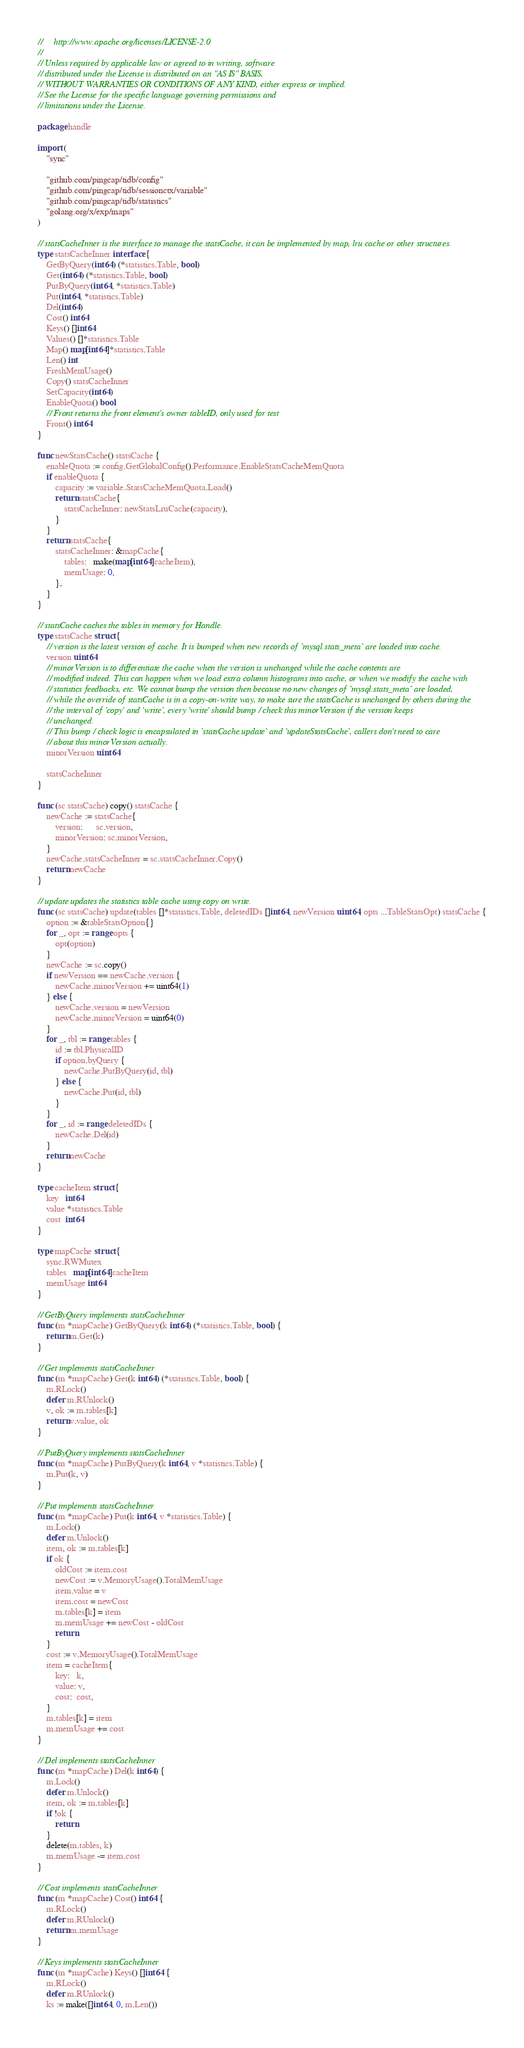<code> <loc_0><loc_0><loc_500><loc_500><_Go_>//     http://www.apache.org/licenses/LICENSE-2.0
//
// Unless required by applicable law or agreed to in writing, software
// distributed under the License is distributed on an "AS IS" BASIS,
// WITHOUT WARRANTIES OR CONDITIONS OF ANY KIND, either express or implied.
// See the License for the specific language governing permissions and
// limitations under the License.

package handle

import (
	"sync"

	"github.com/pingcap/tidb/config"
	"github.com/pingcap/tidb/sessionctx/variable"
	"github.com/pingcap/tidb/statistics"
	"golang.org/x/exp/maps"
)

// statsCacheInner is the interface to manage the statsCache, it can be implemented by map, lru cache or other structures.
type statsCacheInner interface {
	GetByQuery(int64) (*statistics.Table, bool)
	Get(int64) (*statistics.Table, bool)
	PutByQuery(int64, *statistics.Table)
	Put(int64, *statistics.Table)
	Del(int64)
	Cost() int64
	Keys() []int64
	Values() []*statistics.Table
	Map() map[int64]*statistics.Table
	Len() int
	FreshMemUsage()
	Copy() statsCacheInner
	SetCapacity(int64)
	EnableQuota() bool
	// Front returns the front element's owner tableID, only used for test
	Front() int64
}

func newStatsCache() statsCache {
	enableQuota := config.GetGlobalConfig().Performance.EnableStatsCacheMemQuota
	if enableQuota {
		capacity := variable.StatsCacheMemQuota.Load()
		return statsCache{
			statsCacheInner: newStatsLruCache(capacity),
		}
	}
	return statsCache{
		statsCacheInner: &mapCache{
			tables:   make(map[int64]cacheItem),
			memUsage: 0,
		},
	}
}

// statsCache caches the tables in memory for Handle.
type statsCache struct {
	// version is the latest version of cache. It is bumped when new records of `mysql.stats_meta` are loaded into cache.
	version uint64
	// minorVersion is to differentiate the cache when the version is unchanged while the cache contents are
	// modified indeed. This can happen when we load extra column histograms into cache, or when we modify the cache with
	// statistics feedbacks, etc. We cannot bump the version then because no new changes of `mysql.stats_meta` are loaded,
	// while the override of statsCache is in a copy-on-write way, to make sure the statsCache is unchanged by others during the
	// the interval of 'copy' and 'write', every 'write' should bump / check this minorVersion if the version keeps
	// unchanged.
	// This bump / check logic is encapsulated in `statsCache.update` and `updateStatsCache`, callers don't need to care
	// about this minorVersion actually.
	minorVersion uint64

	statsCacheInner
}

func (sc statsCache) copy() statsCache {
	newCache := statsCache{
		version:      sc.version,
		minorVersion: sc.minorVersion,
	}
	newCache.statsCacheInner = sc.statsCacheInner.Copy()
	return newCache
}

// update updates the statistics table cache using copy on write.
func (sc statsCache) update(tables []*statistics.Table, deletedIDs []int64, newVersion uint64, opts ...TableStatsOpt) statsCache {
	option := &tableStatsOption{}
	for _, opt := range opts {
		opt(option)
	}
	newCache := sc.copy()
	if newVersion == newCache.version {
		newCache.minorVersion += uint64(1)
	} else {
		newCache.version = newVersion
		newCache.minorVersion = uint64(0)
	}
	for _, tbl := range tables {
		id := tbl.PhysicalID
		if option.byQuery {
			newCache.PutByQuery(id, tbl)
		} else {
			newCache.Put(id, tbl)
		}
	}
	for _, id := range deletedIDs {
		newCache.Del(id)
	}
	return newCache
}

type cacheItem struct {
	key   int64
	value *statistics.Table
	cost  int64
}

type mapCache struct {
	sync.RWMutex
	tables   map[int64]cacheItem
	memUsage int64
}

// GetByQuery implements statsCacheInner
func (m *mapCache) GetByQuery(k int64) (*statistics.Table, bool) {
	return m.Get(k)
}

// Get implements statsCacheInner
func (m *mapCache) Get(k int64) (*statistics.Table, bool) {
	m.RLock()
	defer m.RUnlock()
	v, ok := m.tables[k]
	return v.value, ok
}

// PutByQuery implements statsCacheInner
func (m *mapCache) PutByQuery(k int64, v *statistics.Table) {
	m.Put(k, v)
}

// Put implements statsCacheInner
func (m *mapCache) Put(k int64, v *statistics.Table) {
	m.Lock()
	defer m.Unlock()
	item, ok := m.tables[k]
	if ok {
		oldCost := item.cost
		newCost := v.MemoryUsage().TotalMemUsage
		item.value = v
		item.cost = newCost
		m.tables[k] = item
		m.memUsage += newCost - oldCost
		return
	}
	cost := v.MemoryUsage().TotalMemUsage
	item = cacheItem{
		key:   k,
		value: v,
		cost:  cost,
	}
	m.tables[k] = item
	m.memUsage += cost
}

// Del implements statsCacheInner
func (m *mapCache) Del(k int64) {
	m.Lock()
	defer m.Unlock()
	item, ok := m.tables[k]
	if !ok {
		return
	}
	delete(m.tables, k)
	m.memUsage -= item.cost
}

// Cost implements statsCacheInner
func (m *mapCache) Cost() int64 {
	m.RLock()
	defer m.RUnlock()
	return m.memUsage
}

// Keys implements statsCacheInner
func (m *mapCache) Keys() []int64 {
	m.RLock()
	defer m.RUnlock()
	ks := make([]int64, 0, m.Len())</code> 